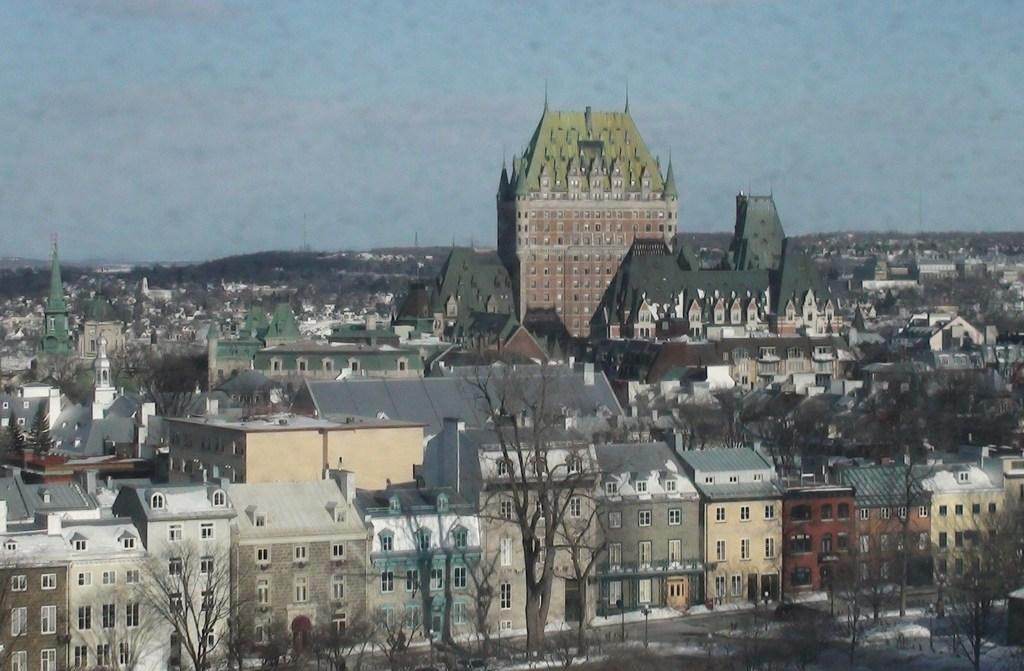What type of vegetation is at the bottom of the image? There are green trees at the bottom of the image. What structures are present in the image? There are very big buildings in the image. What is visible at the top of the image? The sky is visible at the top of the image. What is the opinion of the daughter about the green trees in the image? There is no daughter present in the image, and therefore no opinion can be attributed to her. Can you see any rocks in the image? There is no mention of rocks in the provided facts, and they are not visible in the image. 